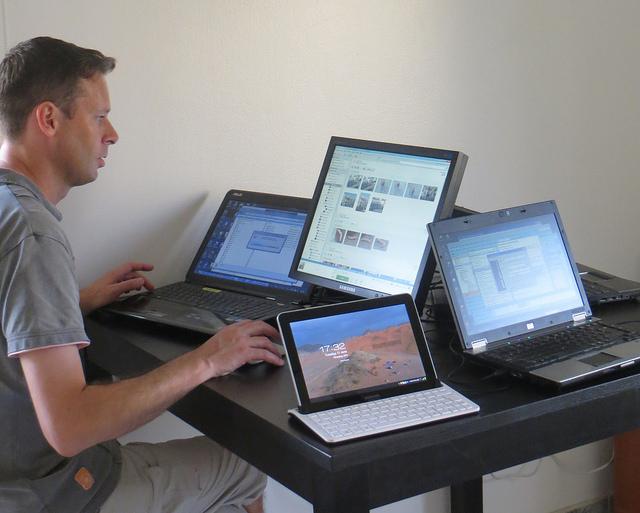How many laptops is on the table?
Quick response, please. 4. Which screen specifically is the man looking at?
Concise answer only. Biggest one. How many laptop computers in this picture?
Be succinct. 4. Is this person a business manager in an office?
Short answer required. Yes. How many computers?
Write a very short answer. 4. What color is the man's shirt?
Concise answer only. Gray. 